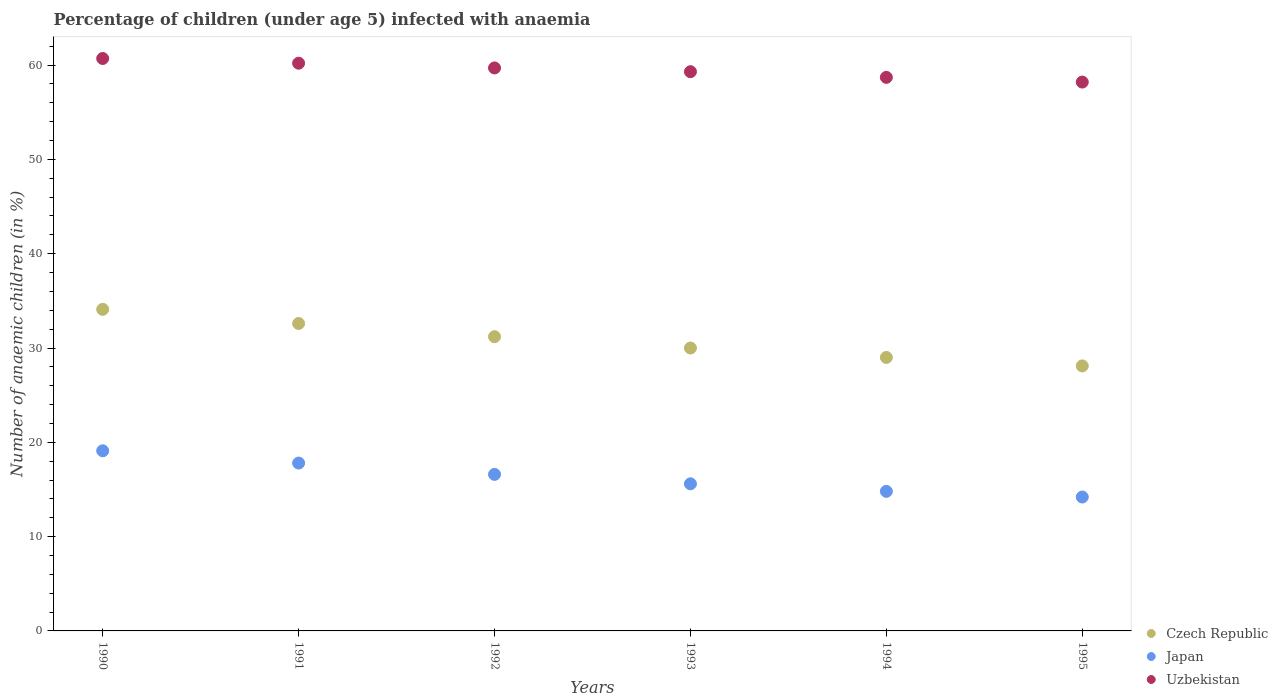How many different coloured dotlines are there?
Your answer should be compact. 3. What is the percentage of children infected with anaemia in in Czech Republic in 1994?
Offer a very short reply. 29. Across all years, what is the maximum percentage of children infected with anaemia in in Uzbekistan?
Provide a short and direct response. 60.7. Across all years, what is the minimum percentage of children infected with anaemia in in Japan?
Offer a very short reply. 14.2. What is the total percentage of children infected with anaemia in in Czech Republic in the graph?
Offer a terse response. 185. What is the difference between the percentage of children infected with anaemia in in Japan in 1990 and that in 1995?
Offer a terse response. 4.9. What is the difference between the percentage of children infected with anaemia in in Uzbekistan in 1991 and the percentage of children infected with anaemia in in Japan in 1992?
Your answer should be compact. 43.6. What is the average percentage of children infected with anaemia in in Uzbekistan per year?
Your answer should be compact. 59.47. In the year 1995, what is the difference between the percentage of children infected with anaemia in in Japan and percentage of children infected with anaemia in in Uzbekistan?
Ensure brevity in your answer.  -44. What is the ratio of the percentage of children infected with anaemia in in Japan in 1990 to that in 1992?
Give a very brief answer. 1.15. Is the percentage of children infected with anaemia in in Japan in 1991 less than that in 1993?
Offer a very short reply. No. What is the difference between the highest and the lowest percentage of children infected with anaemia in in Japan?
Ensure brevity in your answer.  4.9. Is the sum of the percentage of children infected with anaemia in in Uzbekistan in 1993 and 1994 greater than the maximum percentage of children infected with anaemia in in Czech Republic across all years?
Make the answer very short. Yes. Is it the case that in every year, the sum of the percentage of children infected with anaemia in in Uzbekistan and percentage of children infected with anaemia in in Japan  is greater than the percentage of children infected with anaemia in in Czech Republic?
Your answer should be compact. Yes. Is the percentage of children infected with anaemia in in Uzbekistan strictly greater than the percentage of children infected with anaemia in in Czech Republic over the years?
Offer a very short reply. Yes. Is the percentage of children infected with anaemia in in Czech Republic strictly less than the percentage of children infected with anaemia in in Uzbekistan over the years?
Make the answer very short. Yes. How many years are there in the graph?
Your answer should be very brief. 6. Does the graph contain grids?
Offer a very short reply. No. Where does the legend appear in the graph?
Provide a succinct answer. Bottom right. How are the legend labels stacked?
Offer a very short reply. Vertical. What is the title of the graph?
Ensure brevity in your answer.  Percentage of children (under age 5) infected with anaemia. What is the label or title of the X-axis?
Ensure brevity in your answer.  Years. What is the label or title of the Y-axis?
Offer a terse response. Number of anaemic children (in %). What is the Number of anaemic children (in %) in Czech Republic in 1990?
Provide a succinct answer. 34.1. What is the Number of anaemic children (in %) in Uzbekistan in 1990?
Your response must be concise. 60.7. What is the Number of anaemic children (in %) of Czech Republic in 1991?
Provide a succinct answer. 32.6. What is the Number of anaemic children (in %) in Uzbekistan in 1991?
Keep it short and to the point. 60.2. What is the Number of anaemic children (in %) of Czech Republic in 1992?
Your answer should be compact. 31.2. What is the Number of anaemic children (in %) in Uzbekistan in 1992?
Make the answer very short. 59.7. What is the Number of anaemic children (in %) of Uzbekistan in 1993?
Keep it short and to the point. 59.3. What is the Number of anaemic children (in %) in Czech Republic in 1994?
Provide a short and direct response. 29. What is the Number of anaemic children (in %) in Uzbekistan in 1994?
Your answer should be compact. 58.7. What is the Number of anaemic children (in %) of Czech Republic in 1995?
Your response must be concise. 28.1. What is the Number of anaemic children (in %) in Uzbekistan in 1995?
Offer a very short reply. 58.2. Across all years, what is the maximum Number of anaemic children (in %) in Czech Republic?
Give a very brief answer. 34.1. Across all years, what is the maximum Number of anaemic children (in %) of Uzbekistan?
Keep it short and to the point. 60.7. Across all years, what is the minimum Number of anaemic children (in %) of Czech Republic?
Your answer should be compact. 28.1. Across all years, what is the minimum Number of anaemic children (in %) in Uzbekistan?
Offer a very short reply. 58.2. What is the total Number of anaemic children (in %) in Czech Republic in the graph?
Your response must be concise. 185. What is the total Number of anaemic children (in %) of Japan in the graph?
Offer a very short reply. 98.1. What is the total Number of anaemic children (in %) of Uzbekistan in the graph?
Your answer should be very brief. 356.8. What is the difference between the Number of anaemic children (in %) of Japan in 1990 and that in 1991?
Ensure brevity in your answer.  1.3. What is the difference between the Number of anaemic children (in %) in Japan in 1990 and that in 1992?
Offer a terse response. 2.5. What is the difference between the Number of anaemic children (in %) of Uzbekistan in 1990 and that in 1992?
Give a very brief answer. 1. What is the difference between the Number of anaemic children (in %) in Uzbekistan in 1990 and that in 1993?
Your answer should be compact. 1.4. What is the difference between the Number of anaemic children (in %) of Czech Republic in 1990 and that in 1995?
Offer a very short reply. 6. What is the difference between the Number of anaemic children (in %) of Uzbekistan in 1990 and that in 1995?
Ensure brevity in your answer.  2.5. What is the difference between the Number of anaemic children (in %) of Japan in 1991 and that in 1992?
Keep it short and to the point. 1.2. What is the difference between the Number of anaemic children (in %) of Uzbekistan in 1991 and that in 1992?
Your response must be concise. 0.5. What is the difference between the Number of anaemic children (in %) in Uzbekistan in 1991 and that in 1993?
Make the answer very short. 0.9. What is the difference between the Number of anaemic children (in %) in Japan in 1992 and that in 1993?
Your answer should be compact. 1. What is the difference between the Number of anaemic children (in %) in Uzbekistan in 1992 and that in 1993?
Your response must be concise. 0.4. What is the difference between the Number of anaemic children (in %) in Czech Republic in 1992 and that in 1994?
Offer a very short reply. 2.2. What is the difference between the Number of anaemic children (in %) of Czech Republic in 1993 and that in 1994?
Your response must be concise. 1. What is the difference between the Number of anaemic children (in %) in Uzbekistan in 1993 and that in 1995?
Keep it short and to the point. 1.1. What is the difference between the Number of anaemic children (in %) in Japan in 1994 and that in 1995?
Provide a succinct answer. 0.6. What is the difference between the Number of anaemic children (in %) of Czech Republic in 1990 and the Number of anaemic children (in %) of Uzbekistan in 1991?
Provide a short and direct response. -26.1. What is the difference between the Number of anaemic children (in %) of Japan in 1990 and the Number of anaemic children (in %) of Uzbekistan in 1991?
Your answer should be very brief. -41.1. What is the difference between the Number of anaemic children (in %) in Czech Republic in 1990 and the Number of anaemic children (in %) in Uzbekistan in 1992?
Provide a succinct answer. -25.6. What is the difference between the Number of anaemic children (in %) in Japan in 1990 and the Number of anaemic children (in %) in Uzbekistan in 1992?
Provide a short and direct response. -40.6. What is the difference between the Number of anaemic children (in %) of Czech Republic in 1990 and the Number of anaemic children (in %) of Uzbekistan in 1993?
Make the answer very short. -25.2. What is the difference between the Number of anaemic children (in %) in Japan in 1990 and the Number of anaemic children (in %) in Uzbekistan in 1993?
Keep it short and to the point. -40.2. What is the difference between the Number of anaemic children (in %) in Czech Republic in 1990 and the Number of anaemic children (in %) in Japan in 1994?
Provide a short and direct response. 19.3. What is the difference between the Number of anaemic children (in %) of Czech Republic in 1990 and the Number of anaemic children (in %) of Uzbekistan in 1994?
Offer a very short reply. -24.6. What is the difference between the Number of anaemic children (in %) in Japan in 1990 and the Number of anaemic children (in %) in Uzbekistan in 1994?
Give a very brief answer. -39.6. What is the difference between the Number of anaemic children (in %) in Czech Republic in 1990 and the Number of anaemic children (in %) in Japan in 1995?
Your answer should be compact. 19.9. What is the difference between the Number of anaemic children (in %) in Czech Republic in 1990 and the Number of anaemic children (in %) in Uzbekistan in 1995?
Your answer should be compact. -24.1. What is the difference between the Number of anaemic children (in %) in Japan in 1990 and the Number of anaemic children (in %) in Uzbekistan in 1995?
Offer a terse response. -39.1. What is the difference between the Number of anaemic children (in %) in Czech Republic in 1991 and the Number of anaemic children (in %) in Uzbekistan in 1992?
Ensure brevity in your answer.  -27.1. What is the difference between the Number of anaemic children (in %) of Japan in 1991 and the Number of anaemic children (in %) of Uzbekistan in 1992?
Make the answer very short. -41.9. What is the difference between the Number of anaemic children (in %) of Czech Republic in 1991 and the Number of anaemic children (in %) of Japan in 1993?
Offer a very short reply. 17. What is the difference between the Number of anaemic children (in %) in Czech Republic in 1991 and the Number of anaemic children (in %) in Uzbekistan in 1993?
Keep it short and to the point. -26.7. What is the difference between the Number of anaemic children (in %) in Japan in 1991 and the Number of anaemic children (in %) in Uzbekistan in 1993?
Ensure brevity in your answer.  -41.5. What is the difference between the Number of anaemic children (in %) of Czech Republic in 1991 and the Number of anaemic children (in %) of Uzbekistan in 1994?
Your answer should be very brief. -26.1. What is the difference between the Number of anaemic children (in %) of Japan in 1991 and the Number of anaemic children (in %) of Uzbekistan in 1994?
Offer a terse response. -40.9. What is the difference between the Number of anaemic children (in %) in Czech Republic in 1991 and the Number of anaemic children (in %) in Uzbekistan in 1995?
Make the answer very short. -25.6. What is the difference between the Number of anaemic children (in %) of Japan in 1991 and the Number of anaemic children (in %) of Uzbekistan in 1995?
Make the answer very short. -40.4. What is the difference between the Number of anaemic children (in %) in Czech Republic in 1992 and the Number of anaemic children (in %) in Uzbekistan in 1993?
Offer a very short reply. -28.1. What is the difference between the Number of anaemic children (in %) of Japan in 1992 and the Number of anaemic children (in %) of Uzbekistan in 1993?
Keep it short and to the point. -42.7. What is the difference between the Number of anaemic children (in %) in Czech Republic in 1992 and the Number of anaemic children (in %) in Uzbekistan in 1994?
Your answer should be compact. -27.5. What is the difference between the Number of anaemic children (in %) of Japan in 1992 and the Number of anaemic children (in %) of Uzbekistan in 1994?
Your response must be concise. -42.1. What is the difference between the Number of anaemic children (in %) in Czech Republic in 1992 and the Number of anaemic children (in %) in Japan in 1995?
Offer a terse response. 17. What is the difference between the Number of anaemic children (in %) in Japan in 1992 and the Number of anaemic children (in %) in Uzbekistan in 1995?
Your response must be concise. -41.6. What is the difference between the Number of anaemic children (in %) of Czech Republic in 1993 and the Number of anaemic children (in %) of Japan in 1994?
Give a very brief answer. 15.2. What is the difference between the Number of anaemic children (in %) in Czech Republic in 1993 and the Number of anaemic children (in %) in Uzbekistan in 1994?
Your response must be concise. -28.7. What is the difference between the Number of anaemic children (in %) in Japan in 1993 and the Number of anaemic children (in %) in Uzbekistan in 1994?
Keep it short and to the point. -43.1. What is the difference between the Number of anaemic children (in %) of Czech Republic in 1993 and the Number of anaemic children (in %) of Uzbekistan in 1995?
Offer a very short reply. -28.2. What is the difference between the Number of anaemic children (in %) in Japan in 1993 and the Number of anaemic children (in %) in Uzbekistan in 1995?
Your answer should be compact. -42.6. What is the difference between the Number of anaemic children (in %) in Czech Republic in 1994 and the Number of anaemic children (in %) in Uzbekistan in 1995?
Your answer should be very brief. -29.2. What is the difference between the Number of anaemic children (in %) of Japan in 1994 and the Number of anaemic children (in %) of Uzbekistan in 1995?
Your answer should be very brief. -43.4. What is the average Number of anaemic children (in %) of Czech Republic per year?
Offer a terse response. 30.83. What is the average Number of anaemic children (in %) of Japan per year?
Provide a succinct answer. 16.35. What is the average Number of anaemic children (in %) of Uzbekistan per year?
Provide a succinct answer. 59.47. In the year 1990, what is the difference between the Number of anaemic children (in %) of Czech Republic and Number of anaemic children (in %) of Japan?
Make the answer very short. 15. In the year 1990, what is the difference between the Number of anaemic children (in %) in Czech Republic and Number of anaemic children (in %) in Uzbekistan?
Offer a terse response. -26.6. In the year 1990, what is the difference between the Number of anaemic children (in %) of Japan and Number of anaemic children (in %) of Uzbekistan?
Keep it short and to the point. -41.6. In the year 1991, what is the difference between the Number of anaemic children (in %) in Czech Republic and Number of anaemic children (in %) in Japan?
Your answer should be very brief. 14.8. In the year 1991, what is the difference between the Number of anaemic children (in %) in Czech Republic and Number of anaemic children (in %) in Uzbekistan?
Your answer should be very brief. -27.6. In the year 1991, what is the difference between the Number of anaemic children (in %) in Japan and Number of anaemic children (in %) in Uzbekistan?
Your answer should be compact. -42.4. In the year 1992, what is the difference between the Number of anaemic children (in %) of Czech Republic and Number of anaemic children (in %) of Japan?
Offer a very short reply. 14.6. In the year 1992, what is the difference between the Number of anaemic children (in %) of Czech Republic and Number of anaemic children (in %) of Uzbekistan?
Offer a very short reply. -28.5. In the year 1992, what is the difference between the Number of anaemic children (in %) in Japan and Number of anaemic children (in %) in Uzbekistan?
Give a very brief answer. -43.1. In the year 1993, what is the difference between the Number of anaemic children (in %) in Czech Republic and Number of anaemic children (in %) in Uzbekistan?
Your answer should be compact. -29.3. In the year 1993, what is the difference between the Number of anaemic children (in %) in Japan and Number of anaemic children (in %) in Uzbekistan?
Offer a very short reply. -43.7. In the year 1994, what is the difference between the Number of anaemic children (in %) in Czech Republic and Number of anaemic children (in %) in Japan?
Make the answer very short. 14.2. In the year 1994, what is the difference between the Number of anaemic children (in %) in Czech Republic and Number of anaemic children (in %) in Uzbekistan?
Provide a short and direct response. -29.7. In the year 1994, what is the difference between the Number of anaemic children (in %) in Japan and Number of anaemic children (in %) in Uzbekistan?
Provide a short and direct response. -43.9. In the year 1995, what is the difference between the Number of anaemic children (in %) in Czech Republic and Number of anaemic children (in %) in Uzbekistan?
Provide a short and direct response. -30.1. In the year 1995, what is the difference between the Number of anaemic children (in %) of Japan and Number of anaemic children (in %) of Uzbekistan?
Your answer should be very brief. -44. What is the ratio of the Number of anaemic children (in %) in Czech Republic in 1990 to that in 1991?
Your answer should be compact. 1.05. What is the ratio of the Number of anaemic children (in %) of Japan in 1990 to that in 1991?
Provide a short and direct response. 1.07. What is the ratio of the Number of anaemic children (in %) of Uzbekistan in 1990 to that in 1991?
Offer a very short reply. 1.01. What is the ratio of the Number of anaemic children (in %) in Czech Republic in 1990 to that in 1992?
Keep it short and to the point. 1.09. What is the ratio of the Number of anaemic children (in %) in Japan in 1990 to that in 1992?
Offer a terse response. 1.15. What is the ratio of the Number of anaemic children (in %) in Uzbekistan in 1990 to that in 1992?
Provide a short and direct response. 1.02. What is the ratio of the Number of anaemic children (in %) of Czech Republic in 1990 to that in 1993?
Give a very brief answer. 1.14. What is the ratio of the Number of anaemic children (in %) of Japan in 1990 to that in 1993?
Provide a succinct answer. 1.22. What is the ratio of the Number of anaemic children (in %) of Uzbekistan in 1990 to that in 1993?
Your response must be concise. 1.02. What is the ratio of the Number of anaemic children (in %) of Czech Republic in 1990 to that in 1994?
Give a very brief answer. 1.18. What is the ratio of the Number of anaemic children (in %) in Japan in 1990 to that in 1994?
Ensure brevity in your answer.  1.29. What is the ratio of the Number of anaemic children (in %) of Uzbekistan in 1990 to that in 1994?
Offer a terse response. 1.03. What is the ratio of the Number of anaemic children (in %) in Czech Republic in 1990 to that in 1995?
Your response must be concise. 1.21. What is the ratio of the Number of anaemic children (in %) of Japan in 1990 to that in 1995?
Ensure brevity in your answer.  1.35. What is the ratio of the Number of anaemic children (in %) of Uzbekistan in 1990 to that in 1995?
Your answer should be very brief. 1.04. What is the ratio of the Number of anaemic children (in %) in Czech Republic in 1991 to that in 1992?
Offer a very short reply. 1.04. What is the ratio of the Number of anaemic children (in %) in Japan in 1991 to that in 1992?
Keep it short and to the point. 1.07. What is the ratio of the Number of anaemic children (in %) of Uzbekistan in 1991 to that in 1992?
Ensure brevity in your answer.  1.01. What is the ratio of the Number of anaemic children (in %) in Czech Republic in 1991 to that in 1993?
Offer a very short reply. 1.09. What is the ratio of the Number of anaemic children (in %) in Japan in 1991 to that in 1993?
Your answer should be very brief. 1.14. What is the ratio of the Number of anaemic children (in %) in Uzbekistan in 1991 to that in 1993?
Ensure brevity in your answer.  1.02. What is the ratio of the Number of anaemic children (in %) of Czech Republic in 1991 to that in 1994?
Keep it short and to the point. 1.12. What is the ratio of the Number of anaemic children (in %) of Japan in 1991 to that in 1994?
Ensure brevity in your answer.  1.2. What is the ratio of the Number of anaemic children (in %) of Uzbekistan in 1991 to that in 1994?
Provide a short and direct response. 1.03. What is the ratio of the Number of anaemic children (in %) of Czech Republic in 1991 to that in 1995?
Your answer should be very brief. 1.16. What is the ratio of the Number of anaemic children (in %) of Japan in 1991 to that in 1995?
Offer a terse response. 1.25. What is the ratio of the Number of anaemic children (in %) in Uzbekistan in 1991 to that in 1995?
Offer a terse response. 1.03. What is the ratio of the Number of anaemic children (in %) of Czech Republic in 1992 to that in 1993?
Keep it short and to the point. 1.04. What is the ratio of the Number of anaemic children (in %) in Japan in 1992 to that in 1993?
Make the answer very short. 1.06. What is the ratio of the Number of anaemic children (in %) of Uzbekistan in 1992 to that in 1993?
Your answer should be compact. 1.01. What is the ratio of the Number of anaemic children (in %) of Czech Republic in 1992 to that in 1994?
Your response must be concise. 1.08. What is the ratio of the Number of anaemic children (in %) of Japan in 1992 to that in 1994?
Make the answer very short. 1.12. What is the ratio of the Number of anaemic children (in %) of Czech Republic in 1992 to that in 1995?
Ensure brevity in your answer.  1.11. What is the ratio of the Number of anaemic children (in %) in Japan in 1992 to that in 1995?
Your response must be concise. 1.17. What is the ratio of the Number of anaemic children (in %) in Uzbekistan in 1992 to that in 1995?
Make the answer very short. 1.03. What is the ratio of the Number of anaemic children (in %) of Czech Republic in 1993 to that in 1994?
Offer a very short reply. 1.03. What is the ratio of the Number of anaemic children (in %) in Japan in 1993 to that in 1994?
Ensure brevity in your answer.  1.05. What is the ratio of the Number of anaemic children (in %) of Uzbekistan in 1993 to that in 1994?
Provide a succinct answer. 1.01. What is the ratio of the Number of anaemic children (in %) in Czech Republic in 1993 to that in 1995?
Offer a terse response. 1.07. What is the ratio of the Number of anaemic children (in %) of Japan in 1993 to that in 1995?
Provide a short and direct response. 1.1. What is the ratio of the Number of anaemic children (in %) in Uzbekistan in 1993 to that in 1995?
Offer a terse response. 1.02. What is the ratio of the Number of anaemic children (in %) in Czech Republic in 1994 to that in 1995?
Make the answer very short. 1.03. What is the ratio of the Number of anaemic children (in %) of Japan in 1994 to that in 1995?
Offer a very short reply. 1.04. What is the ratio of the Number of anaemic children (in %) of Uzbekistan in 1994 to that in 1995?
Your answer should be compact. 1.01. What is the difference between the highest and the second highest Number of anaemic children (in %) of Japan?
Ensure brevity in your answer.  1.3. What is the difference between the highest and the second highest Number of anaemic children (in %) in Uzbekistan?
Keep it short and to the point. 0.5. What is the difference between the highest and the lowest Number of anaemic children (in %) in Japan?
Make the answer very short. 4.9. 